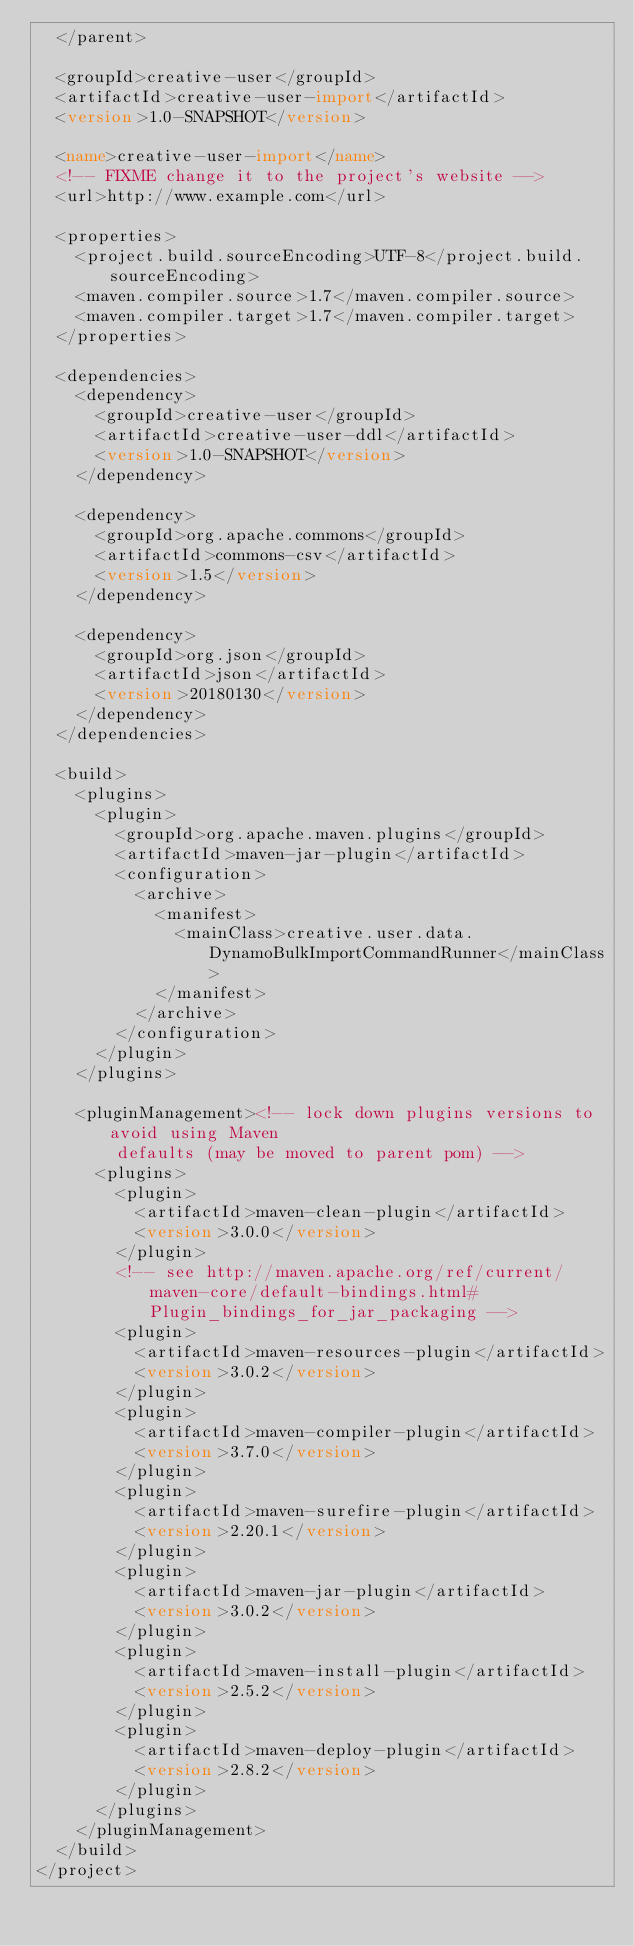<code> <loc_0><loc_0><loc_500><loc_500><_XML_>  </parent>

  <groupId>creative-user</groupId>
  <artifactId>creative-user-import</artifactId>
  <version>1.0-SNAPSHOT</version>

  <name>creative-user-import</name>
  <!-- FIXME change it to the project's website -->
  <url>http://www.example.com</url>

  <properties>
    <project.build.sourceEncoding>UTF-8</project.build.sourceEncoding>
    <maven.compiler.source>1.7</maven.compiler.source>
    <maven.compiler.target>1.7</maven.compiler.target>
  </properties>

  <dependencies>
    <dependency>
      <groupId>creative-user</groupId>
      <artifactId>creative-user-ddl</artifactId>
      <version>1.0-SNAPSHOT</version>
    </dependency>

    <dependency>
      <groupId>org.apache.commons</groupId>
      <artifactId>commons-csv</artifactId>
      <version>1.5</version>
    </dependency>

    <dependency>
      <groupId>org.json</groupId>
      <artifactId>json</artifactId>
      <version>20180130</version>
    </dependency>
  </dependencies>

  <build>
    <plugins>
      <plugin>
        <groupId>org.apache.maven.plugins</groupId>
        <artifactId>maven-jar-plugin</artifactId>
        <configuration>
          <archive>
            <manifest>
              <mainClass>creative.user.data.DynamoBulkImportCommandRunner</mainClass>
            </manifest>
          </archive>
        </configuration>
      </plugin>
    </plugins>

    <pluginManagement><!-- lock down plugins versions to avoid using Maven 
        defaults (may be moved to parent pom) -->
      <plugins>
        <plugin>
          <artifactId>maven-clean-plugin</artifactId>
          <version>3.0.0</version>
        </plugin>
        <!-- see http://maven.apache.org/ref/current/maven-core/default-bindings.html#Plugin_bindings_for_jar_packaging -->
        <plugin>
          <artifactId>maven-resources-plugin</artifactId>
          <version>3.0.2</version>
        </plugin>
        <plugin>
          <artifactId>maven-compiler-plugin</artifactId>
          <version>3.7.0</version>
        </plugin>
        <plugin>
          <artifactId>maven-surefire-plugin</artifactId>
          <version>2.20.1</version>
        </plugin>
        <plugin>
          <artifactId>maven-jar-plugin</artifactId>
          <version>3.0.2</version>
        </plugin>
        <plugin>
          <artifactId>maven-install-plugin</artifactId>
          <version>2.5.2</version>
        </plugin>
        <plugin>
          <artifactId>maven-deploy-plugin</artifactId>
          <version>2.8.2</version>
        </plugin>
      </plugins>
    </pluginManagement>
  </build>
</project>
</code> 